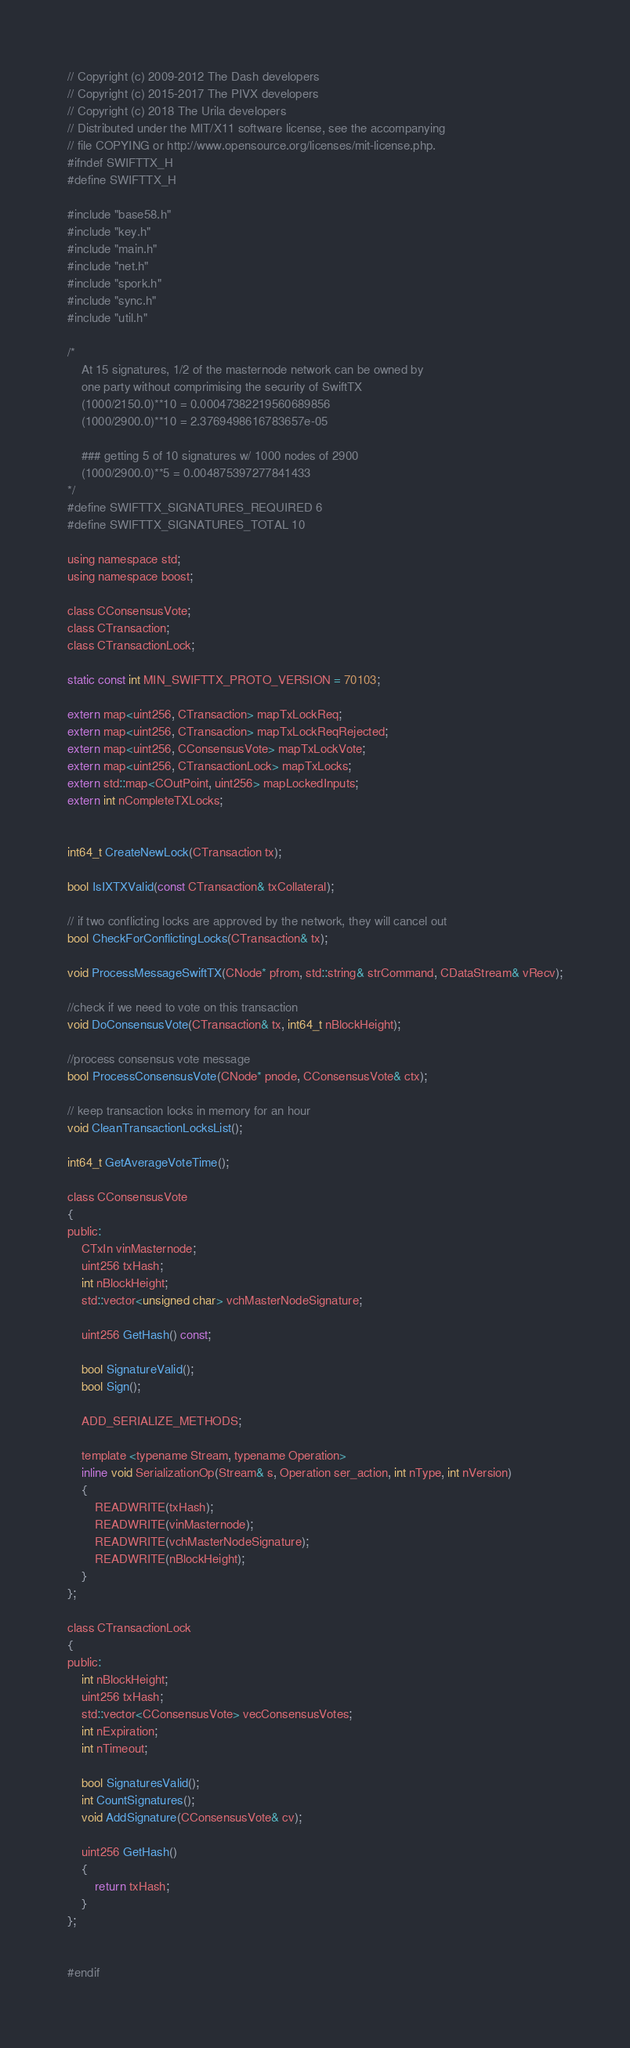<code> <loc_0><loc_0><loc_500><loc_500><_C_>
// Copyright (c) 2009-2012 The Dash developers
// Copyright (c) 2015-2017 The PIVX developers
// Copyright (c) 2018 The Urila developers
// Distributed under the MIT/X11 software license, see the accompanying
// file COPYING or http://www.opensource.org/licenses/mit-license.php.
#ifndef SWIFTTX_H
#define SWIFTTX_H

#include "base58.h"
#include "key.h"
#include "main.h"
#include "net.h"
#include "spork.h"
#include "sync.h"
#include "util.h"

/*
    At 15 signatures, 1/2 of the masternode network can be owned by
    one party without comprimising the security of SwiftTX
    (1000/2150.0)**10 = 0.00047382219560689856
    (1000/2900.0)**10 = 2.3769498616783657e-05

    ### getting 5 of 10 signatures w/ 1000 nodes of 2900
    (1000/2900.0)**5 = 0.004875397277841433
*/
#define SWIFTTX_SIGNATURES_REQUIRED 6
#define SWIFTTX_SIGNATURES_TOTAL 10

using namespace std;
using namespace boost;

class CConsensusVote;
class CTransaction;
class CTransactionLock;

static const int MIN_SWIFTTX_PROTO_VERSION = 70103;

extern map<uint256, CTransaction> mapTxLockReq;
extern map<uint256, CTransaction> mapTxLockReqRejected;
extern map<uint256, CConsensusVote> mapTxLockVote;
extern map<uint256, CTransactionLock> mapTxLocks;
extern std::map<COutPoint, uint256> mapLockedInputs;
extern int nCompleteTXLocks;


int64_t CreateNewLock(CTransaction tx);

bool IsIXTXValid(const CTransaction& txCollateral);

// if two conflicting locks are approved by the network, they will cancel out
bool CheckForConflictingLocks(CTransaction& tx);

void ProcessMessageSwiftTX(CNode* pfrom, std::string& strCommand, CDataStream& vRecv);

//check if we need to vote on this transaction
void DoConsensusVote(CTransaction& tx, int64_t nBlockHeight);

//process consensus vote message
bool ProcessConsensusVote(CNode* pnode, CConsensusVote& ctx);

// keep transaction locks in memory for an hour
void CleanTransactionLocksList();

int64_t GetAverageVoteTime();

class CConsensusVote
{
public:
    CTxIn vinMasternode;
    uint256 txHash;
    int nBlockHeight;
    std::vector<unsigned char> vchMasterNodeSignature;

    uint256 GetHash() const;

    bool SignatureValid();
    bool Sign();

    ADD_SERIALIZE_METHODS;

    template <typename Stream, typename Operation>
    inline void SerializationOp(Stream& s, Operation ser_action, int nType, int nVersion)
    {
        READWRITE(txHash);
        READWRITE(vinMasternode);
        READWRITE(vchMasterNodeSignature);
        READWRITE(nBlockHeight);
    }
};

class CTransactionLock
{
public:
    int nBlockHeight;
    uint256 txHash;
    std::vector<CConsensusVote> vecConsensusVotes;
    int nExpiration;
    int nTimeout;

    bool SignaturesValid();
    int CountSignatures();
    void AddSignature(CConsensusVote& cv);

    uint256 GetHash()
    {
        return txHash;
    }
};


#endif
</code> 